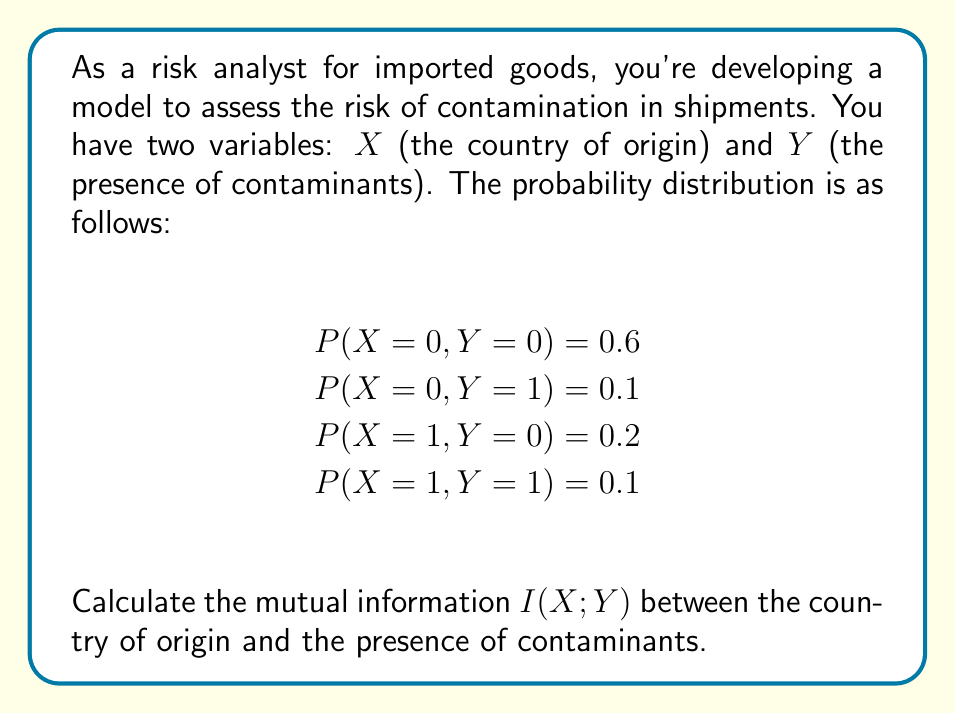Show me your answer to this math problem. To calculate the mutual information I(X;Y), we need to follow these steps:

1. Calculate the marginal probabilities P(X) and P(Y):
   P(X = 0) = 0.6 + 0.1 = 0.7
   P(X = 1) = 0.2 + 0.1 = 0.3
   P(Y = 0) = 0.6 + 0.2 = 0.8
   P(Y = 1) = 0.1 + 0.1 = 0.2

2. Calculate the mutual information using the formula:
   $$I(X;Y) = \sum_{x}\sum_{y} P(x,y) \log_2 \frac{P(x,y)}{P(x)P(y)}$$

3. Apply the formula for each combination of X and Y:

   For X = 0, Y = 0:
   $$0.6 \log_2 \frac{0.6}{0.7 \times 0.8} = 0.6 \log_2 1.0714 = 0.0420$$

   For X = 0, Y = 1:
   $$0.1 \log_2 \frac{0.1}{0.7 \times 0.2} = 0.1 \log_2 0.7143 = -0.0367$$

   For X = 1, Y = 0:
   $$0.2 \log_2 \frac{0.2}{0.3 \times 0.8} = 0.2 \log_2 0.8333 = -0.0284$$

   For X = 1, Y = 1:
   $$0.1 \log_2 \frac{0.1}{0.3 \times 0.2} = 0.1 \log_2 1.6667 = 0.0736$$

4. Sum up all the calculated values:
   $$I(X;Y) = 0.0420 - 0.0367 - 0.0284 + 0.0736 = 0.0505$$

Therefore, the mutual information I(X;Y) is approximately 0.0505 bits.
Answer: I(X;Y) ≈ 0.0505 bits 